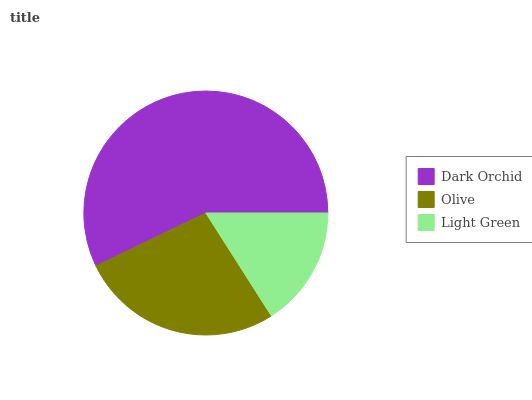Is Light Green the minimum?
Answer yes or no. Yes. Is Dark Orchid the maximum?
Answer yes or no. Yes. Is Olive the minimum?
Answer yes or no. No. Is Olive the maximum?
Answer yes or no. No. Is Dark Orchid greater than Olive?
Answer yes or no. Yes. Is Olive less than Dark Orchid?
Answer yes or no. Yes. Is Olive greater than Dark Orchid?
Answer yes or no. No. Is Dark Orchid less than Olive?
Answer yes or no. No. Is Olive the high median?
Answer yes or no. Yes. Is Olive the low median?
Answer yes or no. Yes. Is Light Green the high median?
Answer yes or no. No. Is Dark Orchid the low median?
Answer yes or no. No. 